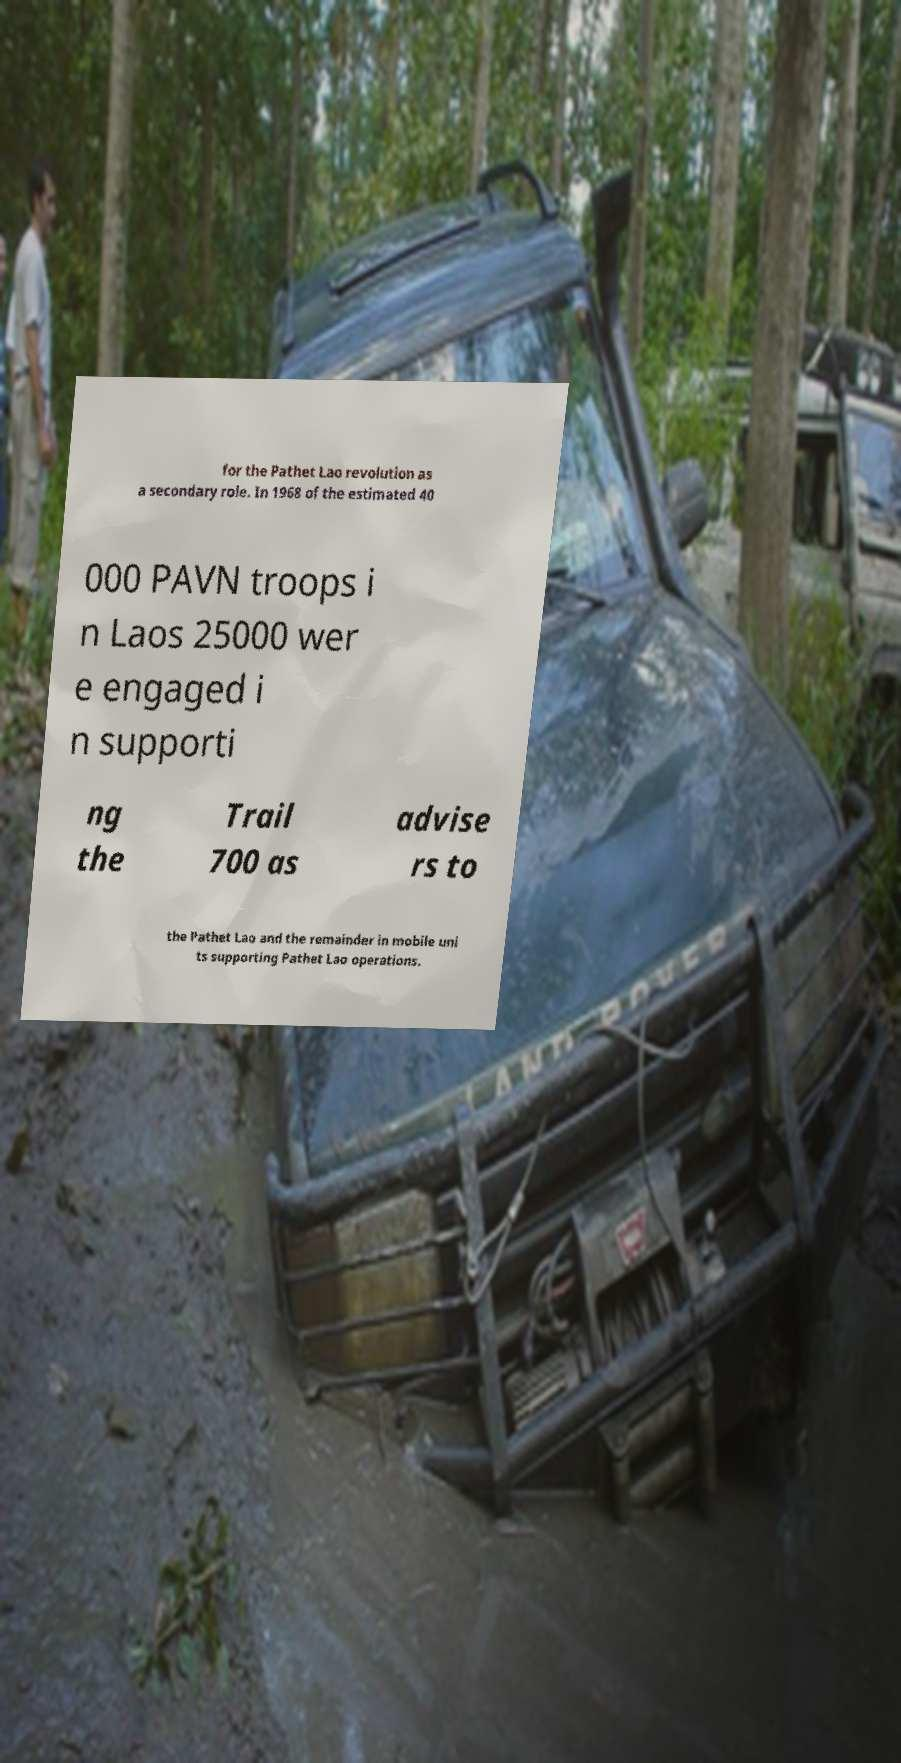I need the written content from this picture converted into text. Can you do that? for the Pathet Lao revolution as a secondary role. In 1968 of the estimated 40 000 PAVN troops i n Laos 25000 wer e engaged i n supporti ng the Trail 700 as advise rs to the Pathet Lao and the remainder in mobile uni ts supporting Pathet Lao operations. 